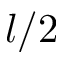<formula> <loc_0><loc_0><loc_500><loc_500>l / 2</formula> 